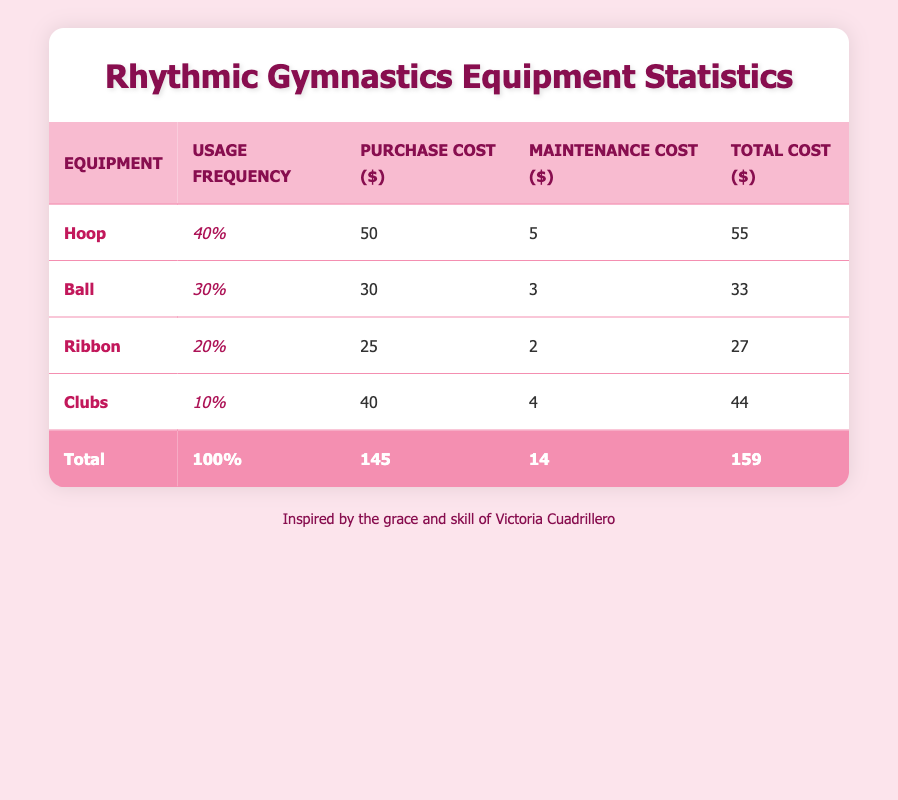What is the usage frequency of the Hoop? The table states that the usage frequency of the Hoop is 40%.
Answer: 40% What are the total expenses for rhythmic gymnastics equipment? The table summarizes the total expenses at the bottom, indicating the total cost is 159.
Answer: 159 What is the purchase cost of the Ball? The table lists the purchase cost of the Ball as 30.
Answer: 30 Is the maintenance cost of the Ribbon greater than that of the Clubs? The table shows that the maintenance cost of the Ribbon is 2, and that of Clubs is 4, thus the statement is false.
Answer: No What is the average total cost of the equipment? We sum the total costs: 55 (Hoop) + 33 (Ball) + 27 (Ribbon) + 44 (Clubs) = 159. There are 4 pieces of equipment, so the average total cost is 159 / 4 = 39.75.
Answer: 39.75 Which equipment has the highest maintenance cost? From the table entries, the Clubs have the highest maintenance cost of 4 compared to the others.
Answer: Clubs What percentage of the total usage frequency does the Ribbon account for? The Ribbon has a usage frequency of 20%, and the total usage frequency sums up to 100%. Therefore, the Ribbon's percentage of total usage is 20%.
Answer: 20% If we only consider the Purchase Costs, what is the difference in expense between the Hoop and the Clubs? The purchase cost of the Hoop is 50 and that of the Clubs is 40. The difference is 50 - 40 = 10.
Answer: 10 How much is spent on maintenance across all equipment? The total maintenance costs from the table are: 5 (Hoop) + 3 (Ball) + 2 (Ribbon) + 4 (Clubs) = 14.
Answer: 14 